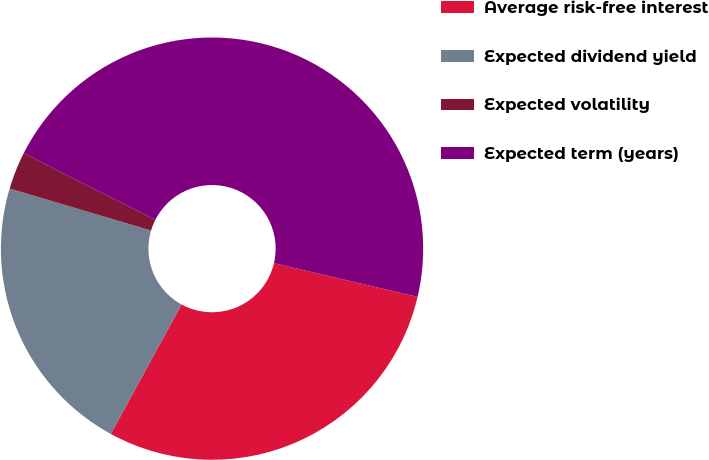Convert chart. <chart><loc_0><loc_0><loc_500><loc_500><pie_chart><fcel>Average risk-free interest<fcel>Expected dividend yield<fcel>Expected volatility<fcel>Expected term (years)<nl><fcel>29.3%<fcel>21.63%<fcel>2.87%<fcel>46.21%<nl></chart> 